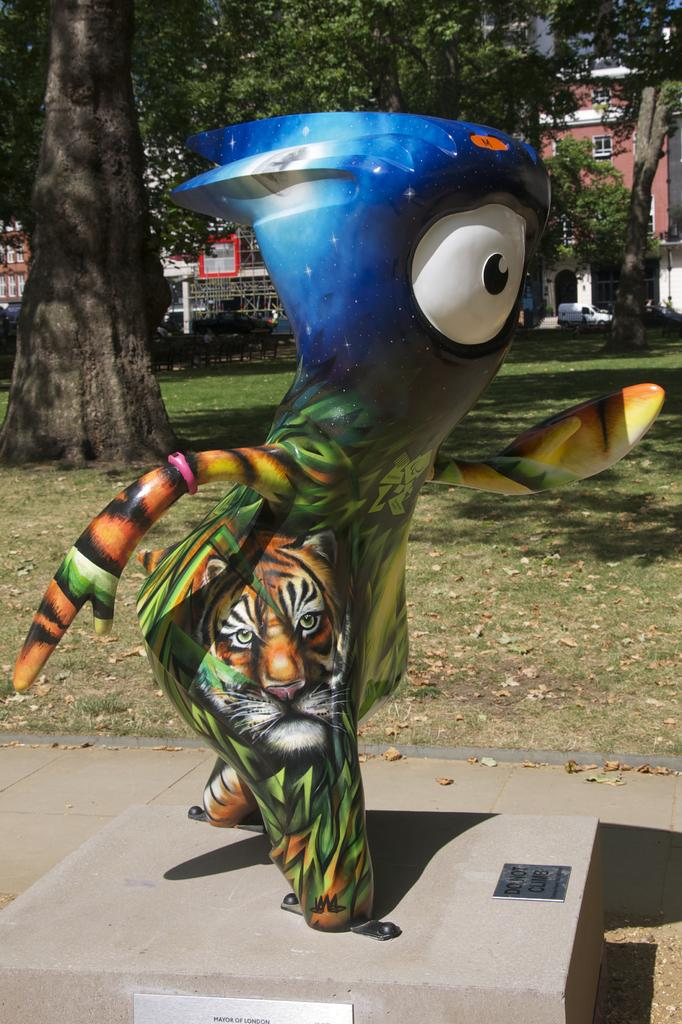What is the main subject in the image? There is a statue in the image. What is the statue resting on? The statue is on an object. What type of natural environment is visible in the background? There is grass, trees, and a building in the background of the image. Can you see a girl interacting with the statue in the image? There is no girl present in the image, and the statue is not interacting with any person. Is there a cobweb visible on the statue in the image? There is no cobweb visible on the statue in the image. 